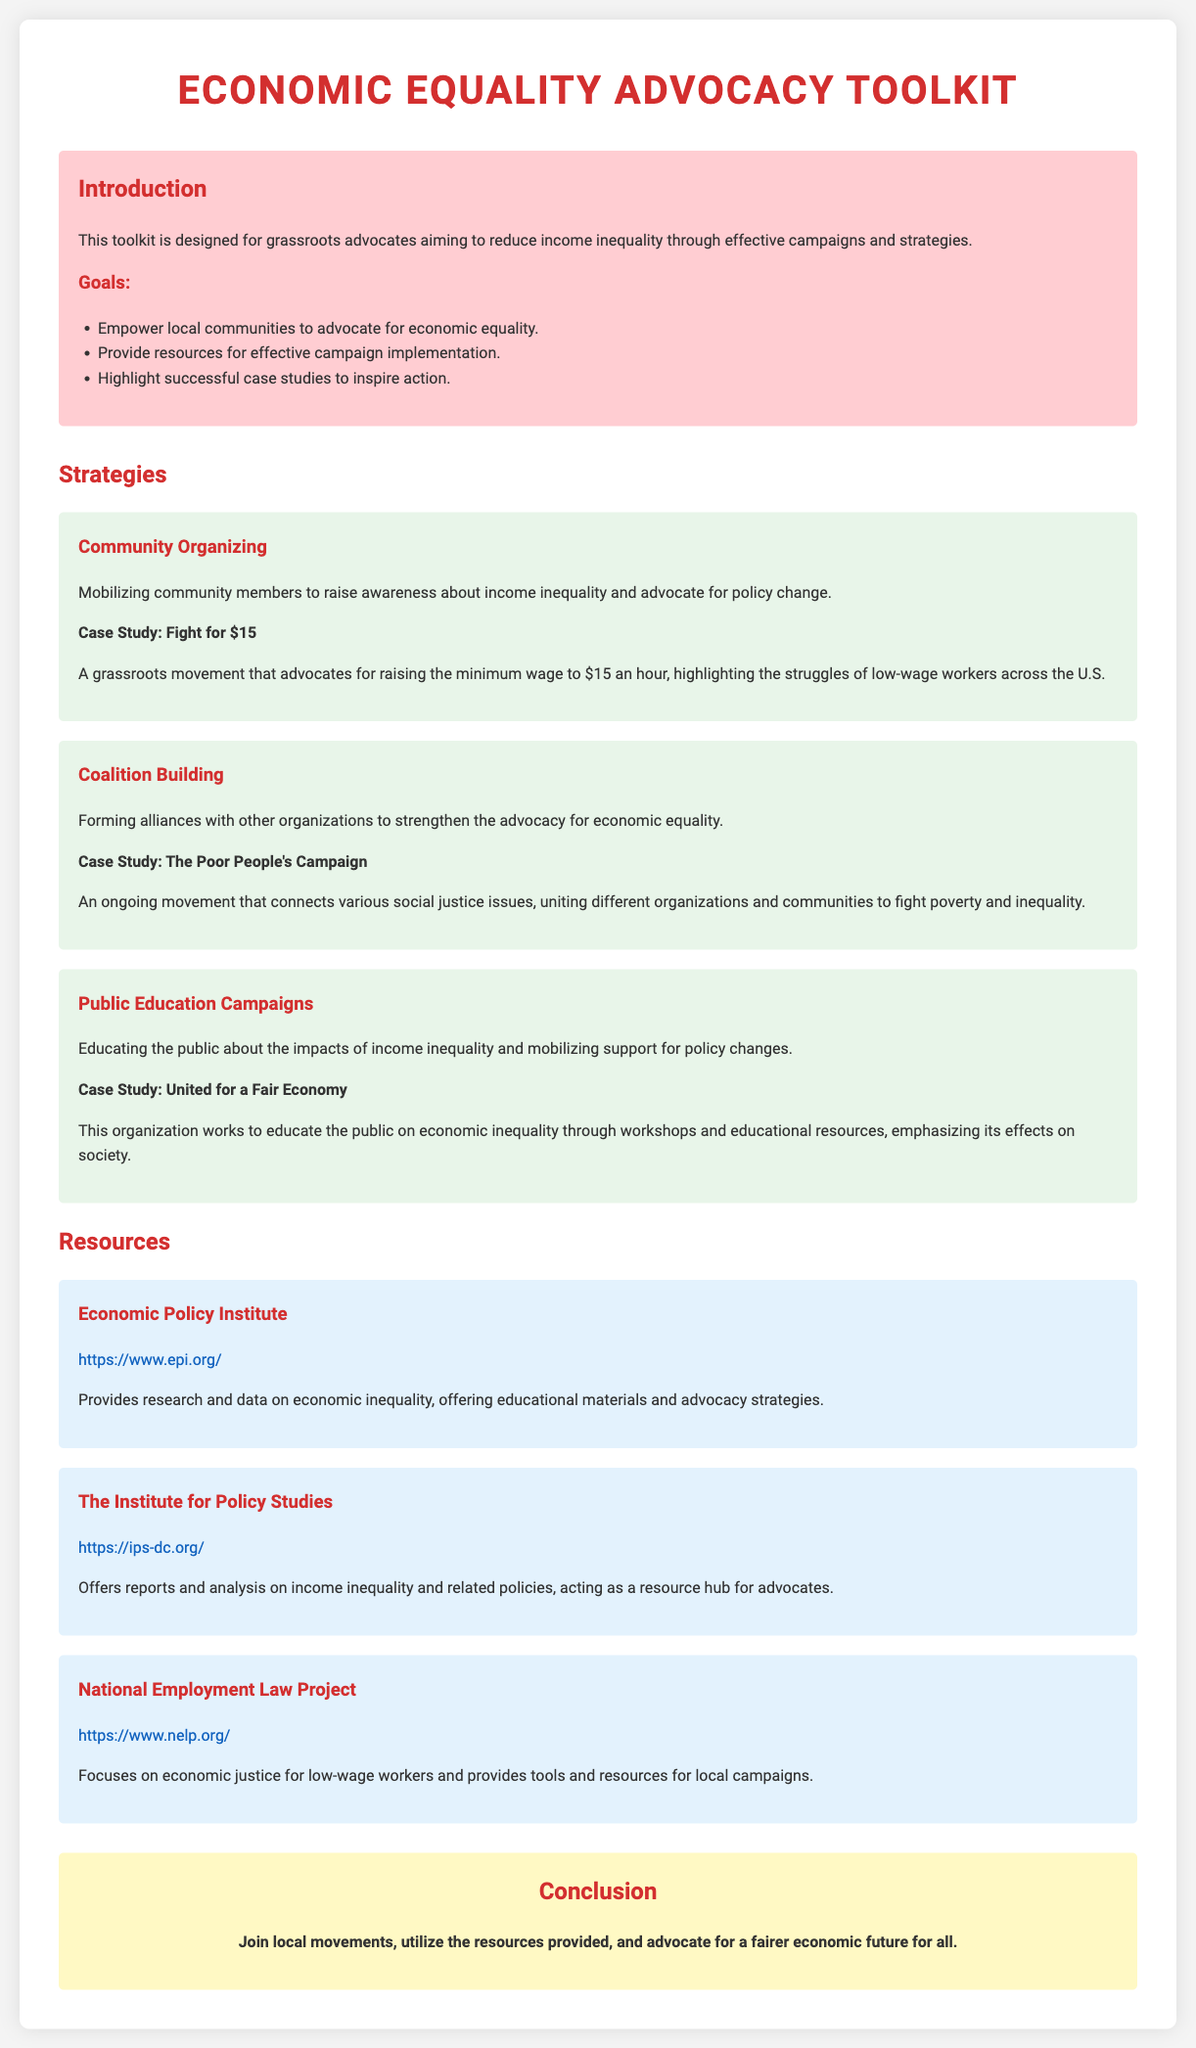What is the title of the toolkit? The title is the primary heading that describes the document's purpose.
Answer: Economic Equality Advocacy Toolkit What is the first goal of the toolkit? The goals section outlines the main aims of the toolkit for grassroots advocates.
Answer: Empower local communities to advocate for economic equality What campaign does the case study "Fight for $15" focus on? This case study emphasizes a specific grassroots movement related to economic policy advocacy.
Answer: Raising the minimum wage to $15 an hour Who provides research on economic inequality according to the resources section? This question refers to the institutions listed that offer supportive material for advocates.
Answer: Economic Policy Institute What type of campaigns does the "Public Education Campaigns" strategy focus on? This strategy section discusses the approach taken to engage the public regarding policies.
Answer: Educating the public What is the website for the National Employment Law Project? This question requests the URL provided for one of the resources listed in the toolkit.
Answer: https://www.nelp.org/ Which case study connects various social justice issues? This question looks for the specific name of an example that illustrates coalition building in advocacy.
Answer: The Poor People's Campaign What color is the background of the introduction section? This question asks about the design element used in the toolkit's introduction.
Answer: Pink 